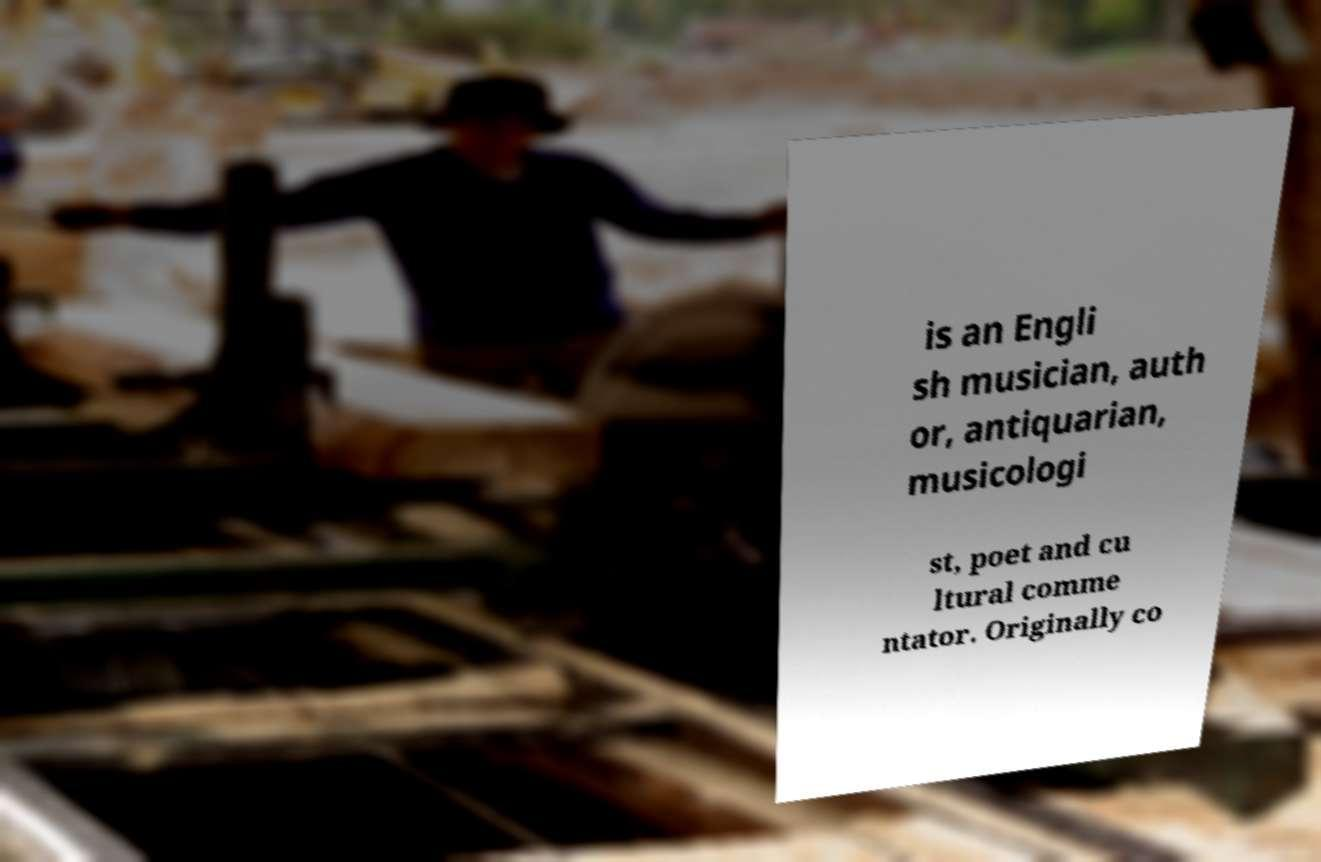I need the written content from this picture converted into text. Can you do that? is an Engli sh musician, auth or, antiquarian, musicologi st, poet and cu ltural comme ntator. Originally co 